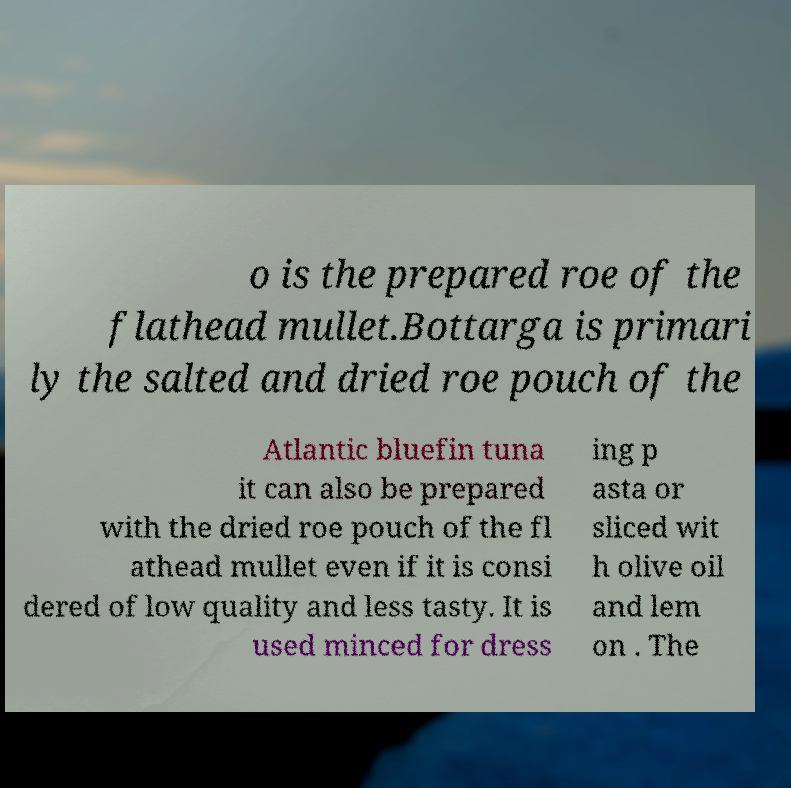Could you extract and type out the text from this image? o is the prepared roe of the flathead mullet.Bottarga is primari ly the salted and dried roe pouch of the Atlantic bluefin tuna it can also be prepared with the dried roe pouch of the fl athead mullet even if it is consi dered of low quality and less tasty. It is used minced for dress ing p asta or sliced wit h olive oil and lem on . The 